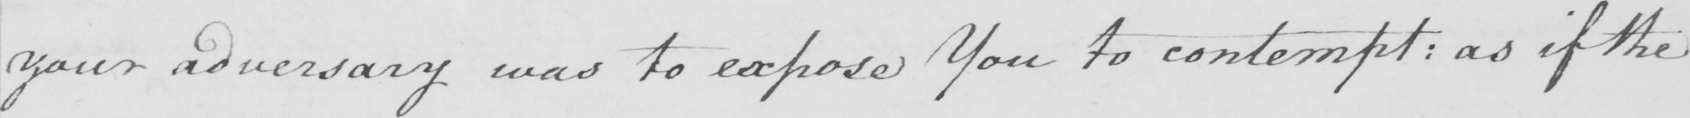What does this handwritten line say? your adversary was to expose You to contempt :  as if the 